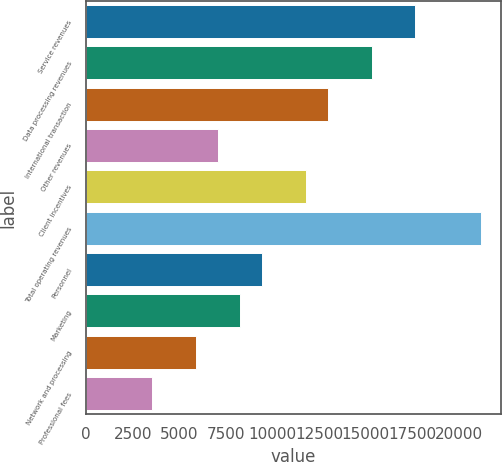Convert chart. <chart><loc_0><loc_0><loc_500><loc_500><bar_chart><fcel>Service revenues<fcel>Data processing revenues<fcel>International transaction<fcel>Other revenues<fcel>Client incentives<fcel>Total operating revenues<fcel>Personnel<fcel>Marketing<fcel>Network and processing<fcel>Professional fees<nl><fcel>17665.5<fcel>15310.5<fcel>12955.5<fcel>7068<fcel>11778<fcel>21198<fcel>9423<fcel>8245.5<fcel>5890.5<fcel>3535.5<nl></chart> 